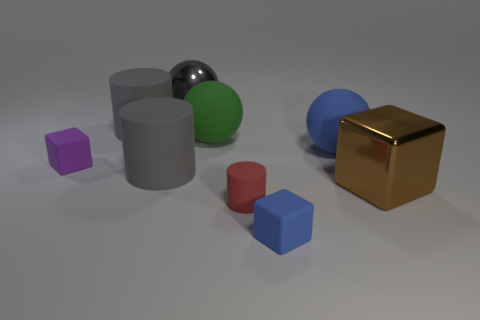Which objects in the image look like they could be stacked on top of each other without falling over? The larger cylinders and the cubes seem to have flat surfaces that would allow them to be stacked securely. Specifically, the silver and green cylinders and gold cube could be stacked with the smaller blue and red cylinders or the purple cube to create a stable arrangement. 